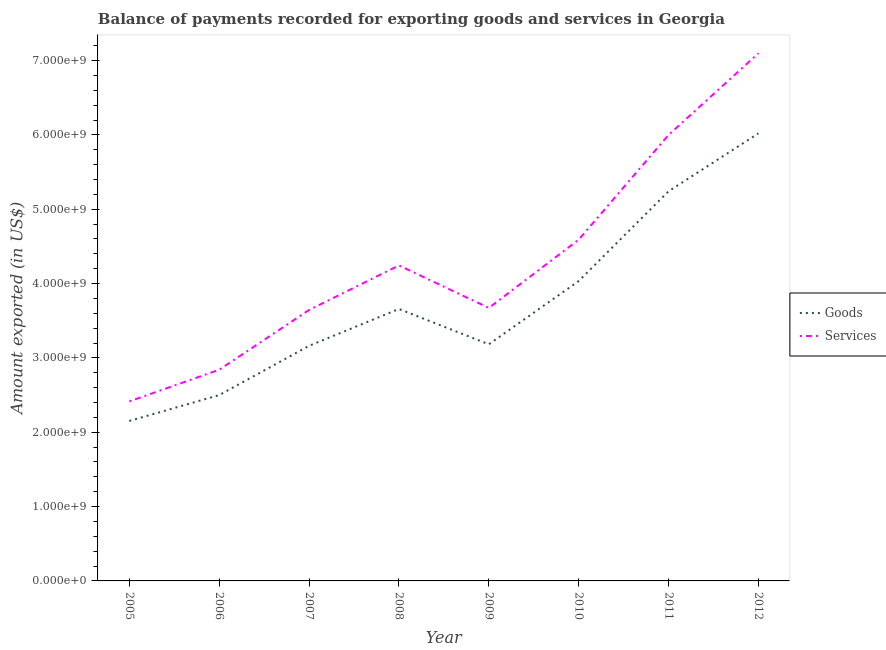What is the amount of services exported in 2009?
Keep it short and to the point. 3.67e+09. Across all years, what is the maximum amount of goods exported?
Provide a succinct answer. 6.02e+09. Across all years, what is the minimum amount of services exported?
Keep it short and to the point. 2.42e+09. In which year was the amount of goods exported maximum?
Your response must be concise. 2012. In which year was the amount of services exported minimum?
Your response must be concise. 2005. What is the total amount of services exported in the graph?
Provide a succinct answer. 3.45e+1. What is the difference between the amount of goods exported in 2007 and that in 2010?
Keep it short and to the point. -8.71e+08. What is the difference between the amount of goods exported in 2010 and the amount of services exported in 2006?
Give a very brief answer. 1.19e+09. What is the average amount of services exported per year?
Offer a terse response. 4.31e+09. In the year 2005, what is the difference between the amount of goods exported and amount of services exported?
Offer a very short reply. -2.63e+08. What is the ratio of the amount of services exported in 2007 to that in 2010?
Give a very brief answer. 0.79. What is the difference between the highest and the second highest amount of goods exported?
Your response must be concise. 7.79e+08. What is the difference between the highest and the lowest amount of services exported?
Your answer should be compact. 4.68e+09. Does the amount of goods exported monotonically increase over the years?
Give a very brief answer. No. Is the amount of goods exported strictly greater than the amount of services exported over the years?
Your answer should be compact. No. What is the difference between two consecutive major ticks on the Y-axis?
Your response must be concise. 1.00e+09. Does the graph contain any zero values?
Offer a terse response. No. Does the graph contain grids?
Give a very brief answer. No. How are the legend labels stacked?
Provide a short and direct response. Vertical. What is the title of the graph?
Keep it short and to the point. Balance of payments recorded for exporting goods and services in Georgia. Does "Underweight" appear as one of the legend labels in the graph?
Your answer should be very brief. No. What is the label or title of the X-axis?
Your answer should be very brief. Year. What is the label or title of the Y-axis?
Ensure brevity in your answer.  Amount exported (in US$). What is the Amount exported (in US$) in Goods in 2005?
Offer a terse response. 2.15e+09. What is the Amount exported (in US$) of Services in 2005?
Your answer should be compact. 2.42e+09. What is the Amount exported (in US$) in Goods in 2006?
Ensure brevity in your answer.  2.50e+09. What is the Amount exported (in US$) of Services in 2006?
Offer a very short reply. 2.84e+09. What is the Amount exported (in US$) of Goods in 2007?
Provide a short and direct response. 3.16e+09. What is the Amount exported (in US$) of Services in 2007?
Provide a succinct answer. 3.65e+09. What is the Amount exported (in US$) in Goods in 2008?
Ensure brevity in your answer.  3.66e+09. What is the Amount exported (in US$) in Services in 2008?
Offer a terse response. 4.24e+09. What is the Amount exported (in US$) of Goods in 2009?
Keep it short and to the point. 3.18e+09. What is the Amount exported (in US$) in Services in 2009?
Your response must be concise. 3.67e+09. What is the Amount exported (in US$) of Goods in 2010?
Ensure brevity in your answer.  4.03e+09. What is the Amount exported (in US$) of Services in 2010?
Offer a very short reply. 4.59e+09. What is the Amount exported (in US$) in Goods in 2011?
Offer a very short reply. 5.24e+09. What is the Amount exported (in US$) in Services in 2011?
Offer a terse response. 6.00e+09. What is the Amount exported (in US$) in Goods in 2012?
Ensure brevity in your answer.  6.02e+09. What is the Amount exported (in US$) in Services in 2012?
Your answer should be very brief. 7.10e+09. Across all years, what is the maximum Amount exported (in US$) of Goods?
Keep it short and to the point. 6.02e+09. Across all years, what is the maximum Amount exported (in US$) in Services?
Provide a succinct answer. 7.10e+09. Across all years, what is the minimum Amount exported (in US$) of Goods?
Offer a terse response. 2.15e+09. Across all years, what is the minimum Amount exported (in US$) in Services?
Your response must be concise. 2.42e+09. What is the total Amount exported (in US$) of Goods in the graph?
Keep it short and to the point. 3.00e+1. What is the total Amount exported (in US$) of Services in the graph?
Keep it short and to the point. 3.45e+1. What is the difference between the Amount exported (in US$) of Goods in 2005 and that in 2006?
Provide a short and direct response. -3.48e+08. What is the difference between the Amount exported (in US$) in Services in 2005 and that in 2006?
Give a very brief answer. -4.26e+08. What is the difference between the Amount exported (in US$) of Goods in 2005 and that in 2007?
Provide a short and direct response. -1.01e+09. What is the difference between the Amount exported (in US$) in Services in 2005 and that in 2007?
Give a very brief answer. -1.23e+09. What is the difference between the Amount exported (in US$) of Goods in 2005 and that in 2008?
Give a very brief answer. -1.51e+09. What is the difference between the Amount exported (in US$) of Services in 2005 and that in 2008?
Your answer should be very brief. -1.83e+09. What is the difference between the Amount exported (in US$) of Goods in 2005 and that in 2009?
Make the answer very short. -1.03e+09. What is the difference between the Amount exported (in US$) in Services in 2005 and that in 2009?
Make the answer very short. -1.26e+09. What is the difference between the Amount exported (in US$) in Goods in 2005 and that in 2010?
Your answer should be very brief. -1.88e+09. What is the difference between the Amount exported (in US$) in Services in 2005 and that in 2010?
Ensure brevity in your answer.  -2.18e+09. What is the difference between the Amount exported (in US$) of Goods in 2005 and that in 2011?
Your response must be concise. -3.09e+09. What is the difference between the Amount exported (in US$) in Services in 2005 and that in 2011?
Ensure brevity in your answer.  -3.58e+09. What is the difference between the Amount exported (in US$) in Goods in 2005 and that in 2012?
Offer a terse response. -3.87e+09. What is the difference between the Amount exported (in US$) in Services in 2005 and that in 2012?
Your answer should be very brief. -4.68e+09. What is the difference between the Amount exported (in US$) in Goods in 2006 and that in 2007?
Your answer should be very brief. -6.63e+08. What is the difference between the Amount exported (in US$) in Services in 2006 and that in 2007?
Provide a succinct answer. -8.04e+08. What is the difference between the Amount exported (in US$) in Goods in 2006 and that in 2008?
Offer a terse response. -1.16e+09. What is the difference between the Amount exported (in US$) in Services in 2006 and that in 2008?
Your response must be concise. -1.40e+09. What is the difference between the Amount exported (in US$) of Goods in 2006 and that in 2009?
Make the answer very short. -6.83e+08. What is the difference between the Amount exported (in US$) of Services in 2006 and that in 2009?
Offer a terse response. -8.31e+08. What is the difference between the Amount exported (in US$) of Goods in 2006 and that in 2010?
Ensure brevity in your answer.  -1.53e+09. What is the difference between the Amount exported (in US$) in Services in 2006 and that in 2010?
Make the answer very short. -1.75e+09. What is the difference between the Amount exported (in US$) of Goods in 2006 and that in 2011?
Your answer should be very brief. -2.74e+09. What is the difference between the Amount exported (in US$) of Services in 2006 and that in 2011?
Offer a very short reply. -3.16e+09. What is the difference between the Amount exported (in US$) in Goods in 2006 and that in 2012?
Keep it short and to the point. -3.52e+09. What is the difference between the Amount exported (in US$) of Services in 2006 and that in 2012?
Ensure brevity in your answer.  -4.26e+09. What is the difference between the Amount exported (in US$) in Goods in 2007 and that in 2008?
Your answer should be very brief. -4.96e+08. What is the difference between the Amount exported (in US$) of Services in 2007 and that in 2008?
Your response must be concise. -5.99e+08. What is the difference between the Amount exported (in US$) in Goods in 2007 and that in 2009?
Provide a succinct answer. -2.04e+07. What is the difference between the Amount exported (in US$) in Services in 2007 and that in 2009?
Keep it short and to the point. -2.71e+07. What is the difference between the Amount exported (in US$) of Goods in 2007 and that in 2010?
Provide a short and direct response. -8.71e+08. What is the difference between the Amount exported (in US$) in Services in 2007 and that in 2010?
Provide a short and direct response. -9.46e+08. What is the difference between the Amount exported (in US$) of Goods in 2007 and that in 2011?
Keep it short and to the point. -2.08e+09. What is the difference between the Amount exported (in US$) of Services in 2007 and that in 2011?
Your answer should be very brief. -2.35e+09. What is the difference between the Amount exported (in US$) of Goods in 2007 and that in 2012?
Make the answer very short. -2.86e+09. What is the difference between the Amount exported (in US$) of Services in 2007 and that in 2012?
Your answer should be very brief. -3.45e+09. What is the difference between the Amount exported (in US$) of Goods in 2008 and that in 2009?
Provide a short and direct response. 4.75e+08. What is the difference between the Amount exported (in US$) of Services in 2008 and that in 2009?
Your answer should be very brief. 5.72e+08. What is the difference between the Amount exported (in US$) of Goods in 2008 and that in 2010?
Give a very brief answer. -3.76e+08. What is the difference between the Amount exported (in US$) of Services in 2008 and that in 2010?
Ensure brevity in your answer.  -3.46e+08. What is the difference between the Amount exported (in US$) in Goods in 2008 and that in 2011?
Ensure brevity in your answer.  -1.58e+09. What is the difference between the Amount exported (in US$) in Services in 2008 and that in 2011?
Provide a short and direct response. -1.76e+09. What is the difference between the Amount exported (in US$) of Goods in 2008 and that in 2012?
Ensure brevity in your answer.  -2.36e+09. What is the difference between the Amount exported (in US$) in Services in 2008 and that in 2012?
Keep it short and to the point. -2.85e+09. What is the difference between the Amount exported (in US$) of Goods in 2009 and that in 2010?
Make the answer very short. -8.51e+08. What is the difference between the Amount exported (in US$) of Services in 2009 and that in 2010?
Your response must be concise. -9.18e+08. What is the difference between the Amount exported (in US$) in Goods in 2009 and that in 2011?
Give a very brief answer. -2.06e+09. What is the difference between the Amount exported (in US$) in Services in 2009 and that in 2011?
Ensure brevity in your answer.  -2.33e+09. What is the difference between the Amount exported (in US$) in Goods in 2009 and that in 2012?
Your answer should be compact. -2.84e+09. What is the difference between the Amount exported (in US$) of Services in 2009 and that in 2012?
Ensure brevity in your answer.  -3.43e+09. What is the difference between the Amount exported (in US$) of Goods in 2010 and that in 2011?
Give a very brief answer. -1.21e+09. What is the difference between the Amount exported (in US$) of Services in 2010 and that in 2011?
Give a very brief answer. -1.41e+09. What is the difference between the Amount exported (in US$) in Goods in 2010 and that in 2012?
Your answer should be compact. -1.99e+09. What is the difference between the Amount exported (in US$) of Services in 2010 and that in 2012?
Offer a terse response. -2.51e+09. What is the difference between the Amount exported (in US$) in Goods in 2011 and that in 2012?
Provide a succinct answer. -7.79e+08. What is the difference between the Amount exported (in US$) in Services in 2011 and that in 2012?
Make the answer very short. -1.10e+09. What is the difference between the Amount exported (in US$) of Goods in 2005 and the Amount exported (in US$) of Services in 2006?
Make the answer very short. -6.89e+08. What is the difference between the Amount exported (in US$) of Goods in 2005 and the Amount exported (in US$) of Services in 2007?
Keep it short and to the point. -1.49e+09. What is the difference between the Amount exported (in US$) of Goods in 2005 and the Amount exported (in US$) of Services in 2008?
Your answer should be compact. -2.09e+09. What is the difference between the Amount exported (in US$) of Goods in 2005 and the Amount exported (in US$) of Services in 2009?
Your answer should be very brief. -1.52e+09. What is the difference between the Amount exported (in US$) in Goods in 2005 and the Amount exported (in US$) in Services in 2010?
Give a very brief answer. -2.44e+09. What is the difference between the Amount exported (in US$) of Goods in 2005 and the Amount exported (in US$) of Services in 2011?
Offer a very short reply. -3.85e+09. What is the difference between the Amount exported (in US$) of Goods in 2005 and the Amount exported (in US$) of Services in 2012?
Keep it short and to the point. -4.95e+09. What is the difference between the Amount exported (in US$) of Goods in 2006 and the Amount exported (in US$) of Services in 2007?
Give a very brief answer. -1.15e+09. What is the difference between the Amount exported (in US$) in Goods in 2006 and the Amount exported (in US$) in Services in 2008?
Your response must be concise. -1.74e+09. What is the difference between the Amount exported (in US$) in Goods in 2006 and the Amount exported (in US$) in Services in 2009?
Keep it short and to the point. -1.17e+09. What is the difference between the Amount exported (in US$) of Goods in 2006 and the Amount exported (in US$) of Services in 2010?
Provide a short and direct response. -2.09e+09. What is the difference between the Amount exported (in US$) of Goods in 2006 and the Amount exported (in US$) of Services in 2011?
Your response must be concise. -3.50e+09. What is the difference between the Amount exported (in US$) of Goods in 2006 and the Amount exported (in US$) of Services in 2012?
Make the answer very short. -4.60e+09. What is the difference between the Amount exported (in US$) in Goods in 2007 and the Amount exported (in US$) in Services in 2008?
Your response must be concise. -1.08e+09. What is the difference between the Amount exported (in US$) in Goods in 2007 and the Amount exported (in US$) in Services in 2009?
Offer a very short reply. -5.10e+08. What is the difference between the Amount exported (in US$) in Goods in 2007 and the Amount exported (in US$) in Services in 2010?
Give a very brief answer. -1.43e+09. What is the difference between the Amount exported (in US$) in Goods in 2007 and the Amount exported (in US$) in Services in 2011?
Make the answer very short. -2.84e+09. What is the difference between the Amount exported (in US$) in Goods in 2007 and the Amount exported (in US$) in Services in 2012?
Give a very brief answer. -3.94e+09. What is the difference between the Amount exported (in US$) of Goods in 2008 and the Amount exported (in US$) of Services in 2009?
Provide a succinct answer. -1.38e+07. What is the difference between the Amount exported (in US$) in Goods in 2008 and the Amount exported (in US$) in Services in 2010?
Give a very brief answer. -9.32e+08. What is the difference between the Amount exported (in US$) of Goods in 2008 and the Amount exported (in US$) of Services in 2011?
Provide a succinct answer. -2.34e+09. What is the difference between the Amount exported (in US$) in Goods in 2008 and the Amount exported (in US$) in Services in 2012?
Provide a short and direct response. -3.44e+09. What is the difference between the Amount exported (in US$) of Goods in 2009 and the Amount exported (in US$) of Services in 2010?
Your answer should be compact. -1.41e+09. What is the difference between the Amount exported (in US$) of Goods in 2009 and the Amount exported (in US$) of Services in 2011?
Offer a terse response. -2.82e+09. What is the difference between the Amount exported (in US$) of Goods in 2009 and the Amount exported (in US$) of Services in 2012?
Make the answer very short. -3.92e+09. What is the difference between the Amount exported (in US$) in Goods in 2010 and the Amount exported (in US$) in Services in 2011?
Your answer should be compact. -1.97e+09. What is the difference between the Amount exported (in US$) of Goods in 2010 and the Amount exported (in US$) of Services in 2012?
Make the answer very short. -3.06e+09. What is the difference between the Amount exported (in US$) in Goods in 2011 and the Amount exported (in US$) in Services in 2012?
Give a very brief answer. -1.86e+09. What is the average Amount exported (in US$) in Goods per year?
Keep it short and to the point. 3.74e+09. What is the average Amount exported (in US$) in Services per year?
Provide a short and direct response. 4.31e+09. In the year 2005, what is the difference between the Amount exported (in US$) in Goods and Amount exported (in US$) in Services?
Your answer should be compact. -2.63e+08. In the year 2006, what is the difference between the Amount exported (in US$) in Goods and Amount exported (in US$) in Services?
Provide a succinct answer. -3.41e+08. In the year 2007, what is the difference between the Amount exported (in US$) of Goods and Amount exported (in US$) of Services?
Offer a very short reply. -4.83e+08. In the year 2008, what is the difference between the Amount exported (in US$) in Goods and Amount exported (in US$) in Services?
Offer a terse response. -5.86e+08. In the year 2009, what is the difference between the Amount exported (in US$) of Goods and Amount exported (in US$) of Services?
Give a very brief answer. -4.89e+08. In the year 2010, what is the difference between the Amount exported (in US$) in Goods and Amount exported (in US$) in Services?
Keep it short and to the point. -5.57e+08. In the year 2011, what is the difference between the Amount exported (in US$) in Goods and Amount exported (in US$) in Services?
Provide a succinct answer. -7.58e+08. In the year 2012, what is the difference between the Amount exported (in US$) of Goods and Amount exported (in US$) of Services?
Offer a very short reply. -1.08e+09. What is the ratio of the Amount exported (in US$) of Goods in 2005 to that in 2006?
Keep it short and to the point. 0.86. What is the ratio of the Amount exported (in US$) in Services in 2005 to that in 2006?
Your answer should be compact. 0.85. What is the ratio of the Amount exported (in US$) of Goods in 2005 to that in 2007?
Make the answer very short. 0.68. What is the ratio of the Amount exported (in US$) of Services in 2005 to that in 2007?
Your response must be concise. 0.66. What is the ratio of the Amount exported (in US$) in Goods in 2005 to that in 2008?
Give a very brief answer. 0.59. What is the ratio of the Amount exported (in US$) of Services in 2005 to that in 2008?
Provide a short and direct response. 0.57. What is the ratio of the Amount exported (in US$) in Goods in 2005 to that in 2009?
Offer a terse response. 0.68. What is the ratio of the Amount exported (in US$) of Services in 2005 to that in 2009?
Keep it short and to the point. 0.66. What is the ratio of the Amount exported (in US$) of Goods in 2005 to that in 2010?
Provide a short and direct response. 0.53. What is the ratio of the Amount exported (in US$) in Services in 2005 to that in 2010?
Provide a succinct answer. 0.53. What is the ratio of the Amount exported (in US$) in Goods in 2005 to that in 2011?
Your answer should be compact. 0.41. What is the ratio of the Amount exported (in US$) of Services in 2005 to that in 2011?
Your answer should be very brief. 0.4. What is the ratio of the Amount exported (in US$) of Goods in 2005 to that in 2012?
Your response must be concise. 0.36. What is the ratio of the Amount exported (in US$) in Services in 2005 to that in 2012?
Give a very brief answer. 0.34. What is the ratio of the Amount exported (in US$) of Goods in 2006 to that in 2007?
Provide a short and direct response. 0.79. What is the ratio of the Amount exported (in US$) of Services in 2006 to that in 2007?
Your answer should be very brief. 0.78. What is the ratio of the Amount exported (in US$) in Goods in 2006 to that in 2008?
Make the answer very short. 0.68. What is the ratio of the Amount exported (in US$) in Services in 2006 to that in 2008?
Provide a succinct answer. 0.67. What is the ratio of the Amount exported (in US$) of Goods in 2006 to that in 2009?
Your answer should be compact. 0.79. What is the ratio of the Amount exported (in US$) of Services in 2006 to that in 2009?
Offer a terse response. 0.77. What is the ratio of the Amount exported (in US$) of Goods in 2006 to that in 2010?
Provide a short and direct response. 0.62. What is the ratio of the Amount exported (in US$) in Services in 2006 to that in 2010?
Give a very brief answer. 0.62. What is the ratio of the Amount exported (in US$) of Goods in 2006 to that in 2011?
Your response must be concise. 0.48. What is the ratio of the Amount exported (in US$) of Services in 2006 to that in 2011?
Make the answer very short. 0.47. What is the ratio of the Amount exported (in US$) in Goods in 2006 to that in 2012?
Give a very brief answer. 0.42. What is the ratio of the Amount exported (in US$) of Services in 2006 to that in 2012?
Provide a succinct answer. 0.4. What is the ratio of the Amount exported (in US$) in Goods in 2007 to that in 2008?
Your answer should be compact. 0.86. What is the ratio of the Amount exported (in US$) in Services in 2007 to that in 2008?
Provide a short and direct response. 0.86. What is the ratio of the Amount exported (in US$) of Goods in 2007 to that in 2009?
Offer a very short reply. 0.99. What is the ratio of the Amount exported (in US$) in Goods in 2007 to that in 2010?
Your answer should be compact. 0.78. What is the ratio of the Amount exported (in US$) of Services in 2007 to that in 2010?
Give a very brief answer. 0.79. What is the ratio of the Amount exported (in US$) of Goods in 2007 to that in 2011?
Your answer should be very brief. 0.6. What is the ratio of the Amount exported (in US$) of Services in 2007 to that in 2011?
Your answer should be compact. 0.61. What is the ratio of the Amount exported (in US$) of Goods in 2007 to that in 2012?
Your response must be concise. 0.53. What is the ratio of the Amount exported (in US$) in Services in 2007 to that in 2012?
Provide a short and direct response. 0.51. What is the ratio of the Amount exported (in US$) in Goods in 2008 to that in 2009?
Keep it short and to the point. 1.15. What is the ratio of the Amount exported (in US$) in Services in 2008 to that in 2009?
Ensure brevity in your answer.  1.16. What is the ratio of the Amount exported (in US$) of Goods in 2008 to that in 2010?
Keep it short and to the point. 0.91. What is the ratio of the Amount exported (in US$) of Services in 2008 to that in 2010?
Your answer should be very brief. 0.92. What is the ratio of the Amount exported (in US$) of Goods in 2008 to that in 2011?
Ensure brevity in your answer.  0.7. What is the ratio of the Amount exported (in US$) of Services in 2008 to that in 2011?
Keep it short and to the point. 0.71. What is the ratio of the Amount exported (in US$) in Goods in 2008 to that in 2012?
Your response must be concise. 0.61. What is the ratio of the Amount exported (in US$) of Services in 2008 to that in 2012?
Your response must be concise. 0.6. What is the ratio of the Amount exported (in US$) of Goods in 2009 to that in 2010?
Provide a succinct answer. 0.79. What is the ratio of the Amount exported (in US$) in Services in 2009 to that in 2010?
Offer a terse response. 0.8. What is the ratio of the Amount exported (in US$) in Goods in 2009 to that in 2011?
Ensure brevity in your answer.  0.61. What is the ratio of the Amount exported (in US$) of Services in 2009 to that in 2011?
Provide a succinct answer. 0.61. What is the ratio of the Amount exported (in US$) of Goods in 2009 to that in 2012?
Offer a terse response. 0.53. What is the ratio of the Amount exported (in US$) of Services in 2009 to that in 2012?
Your answer should be very brief. 0.52. What is the ratio of the Amount exported (in US$) of Goods in 2010 to that in 2011?
Keep it short and to the point. 0.77. What is the ratio of the Amount exported (in US$) of Services in 2010 to that in 2011?
Offer a very short reply. 0.77. What is the ratio of the Amount exported (in US$) of Goods in 2010 to that in 2012?
Offer a very short reply. 0.67. What is the ratio of the Amount exported (in US$) in Services in 2010 to that in 2012?
Offer a very short reply. 0.65. What is the ratio of the Amount exported (in US$) in Goods in 2011 to that in 2012?
Give a very brief answer. 0.87. What is the ratio of the Amount exported (in US$) of Services in 2011 to that in 2012?
Your response must be concise. 0.85. What is the difference between the highest and the second highest Amount exported (in US$) of Goods?
Ensure brevity in your answer.  7.79e+08. What is the difference between the highest and the second highest Amount exported (in US$) in Services?
Your answer should be compact. 1.10e+09. What is the difference between the highest and the lowest Amount exported (in US$) of Goods?
Ensure brevity in your answer.  3.87e+09. What is the difference between the highest and the lowest Amount exported (in US$) of Services?
Your answer should be compact. 4.68e+09. 